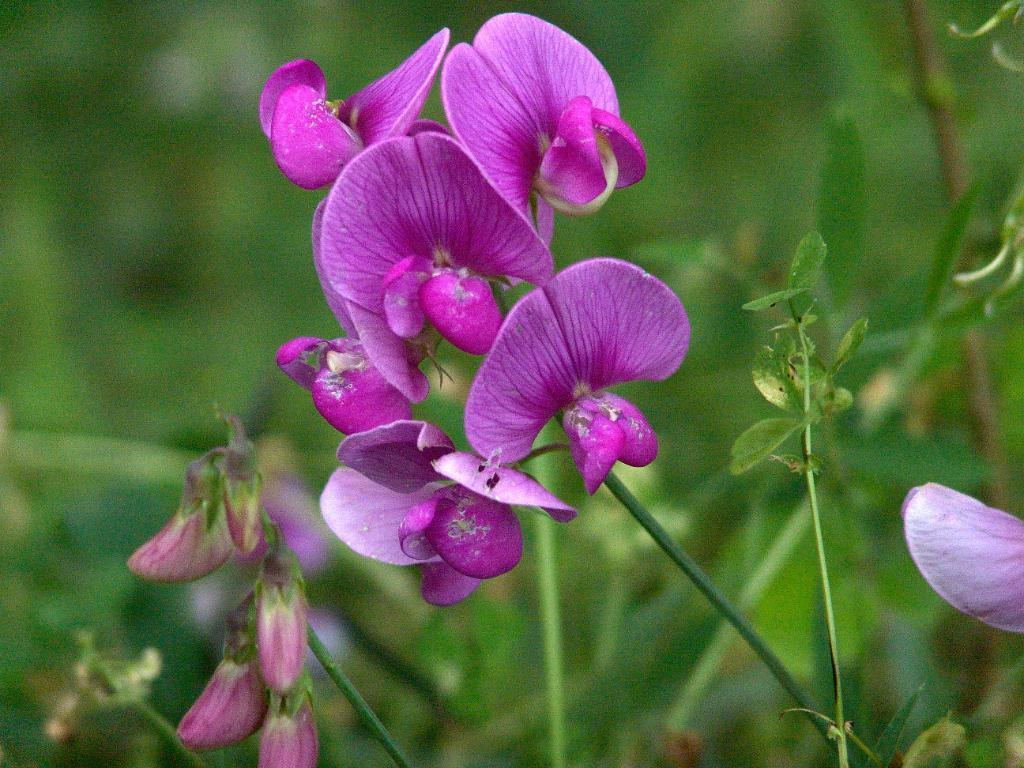What type of flowers can be seen in the image? There are purple color flowers in the image. What color are the leaves in the image? The leaves in the image are green. How would you describe the overall clarity of the image? The image is slightly blurry in the background. Can you see any celery in the image? There is no celery present in the image. What type of boats can be seen in the harbor in the image? There is no harbor or boats present in the image; it features flowers and leaves. 